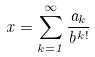<formula> <loc_0><loc_0><loc_500><loc_500>x = \sum _ { k = 1 } ^ { \infty } \frac { a _ { k } } { b ^ { k ! } }</formula> 